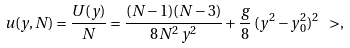Convert formula to latex. <formula><loc_0><loc_0><loc_500><loc_500>u ( y , N ) = \frac { U ( y ) } { N } = \frac { ( N - 1 ) ( N - 3 ) } { 8 N ^ { 2 } \, y ^ { 2 } } + \frac { g } { 8 } \, ( y ^ { 2 } - y _ { 0 } ^ { 2 } ) ^ { 2 } \ > ,</formula> 